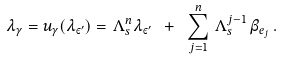<formula> <loc_0><loc_0><loc_500><loc_500>\lambda _ { \gamma } = u _ { \gamma } ( \lambda _ { \varepsilon ^ { \prime } } ) = \, \Lambda _ { s } ^ { n } \lambda _ { \varepsilon ^ { \prime } } \ + \ \sum _ { j = 1 } ^ { n } \, \Lambda _ { s } ^ { j - 1 } \, \beta _ { e _ { j } } \, .</formula> 